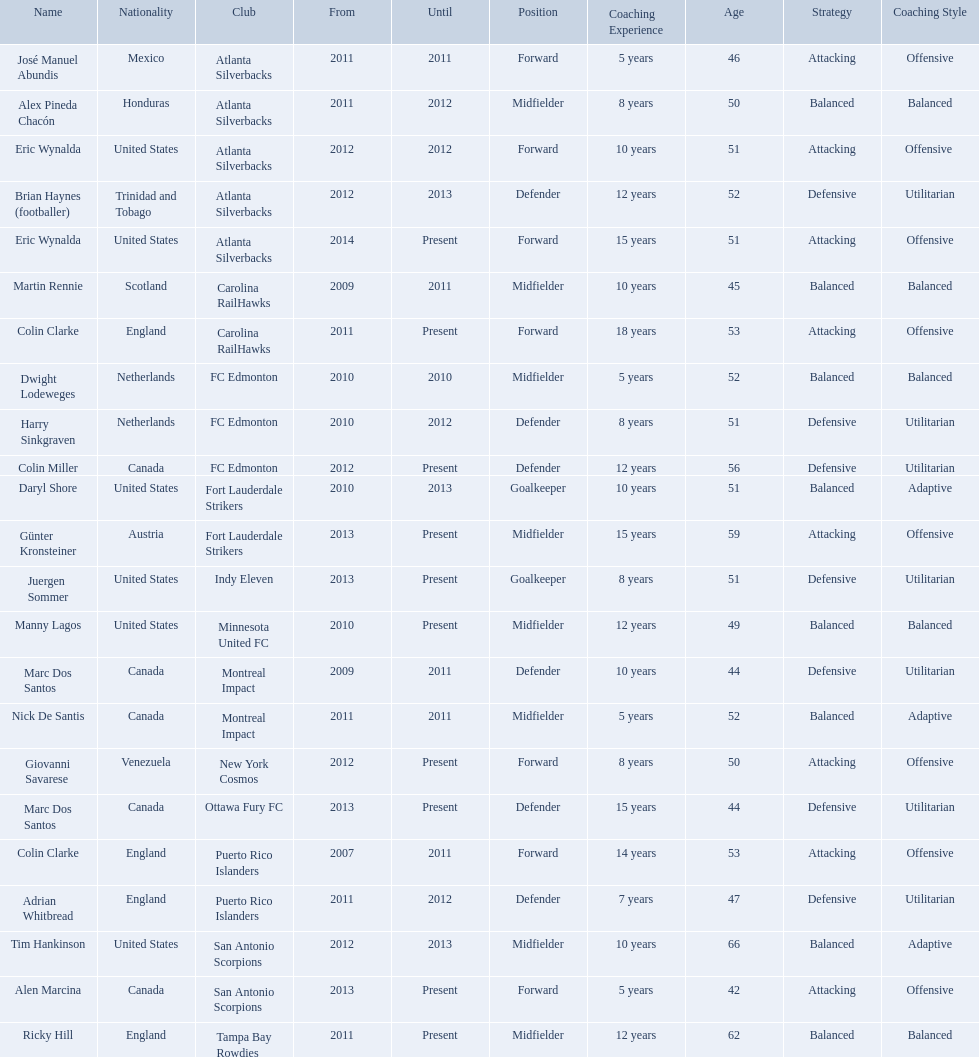What year did marc dos santos start as coach? 2009. Which other starting years correspond with this year? 2009. Who was the other coach with this starting year Martin Rennie. What year did marc dos santos start as coach? 2009. Besides marc dos santos, what other coach started in 2009? Martin Rennie. 